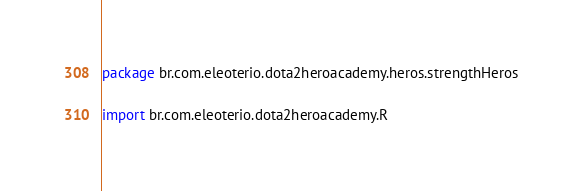Convert code to text. <code><loc_0><loc_0><loc_500><loc_500><_Kotlin_>package br.com.eleoterio.dota2heroacademy.heros.strengthHeros

import br.com.eleoterio.dota2heroacademy.R</code> 